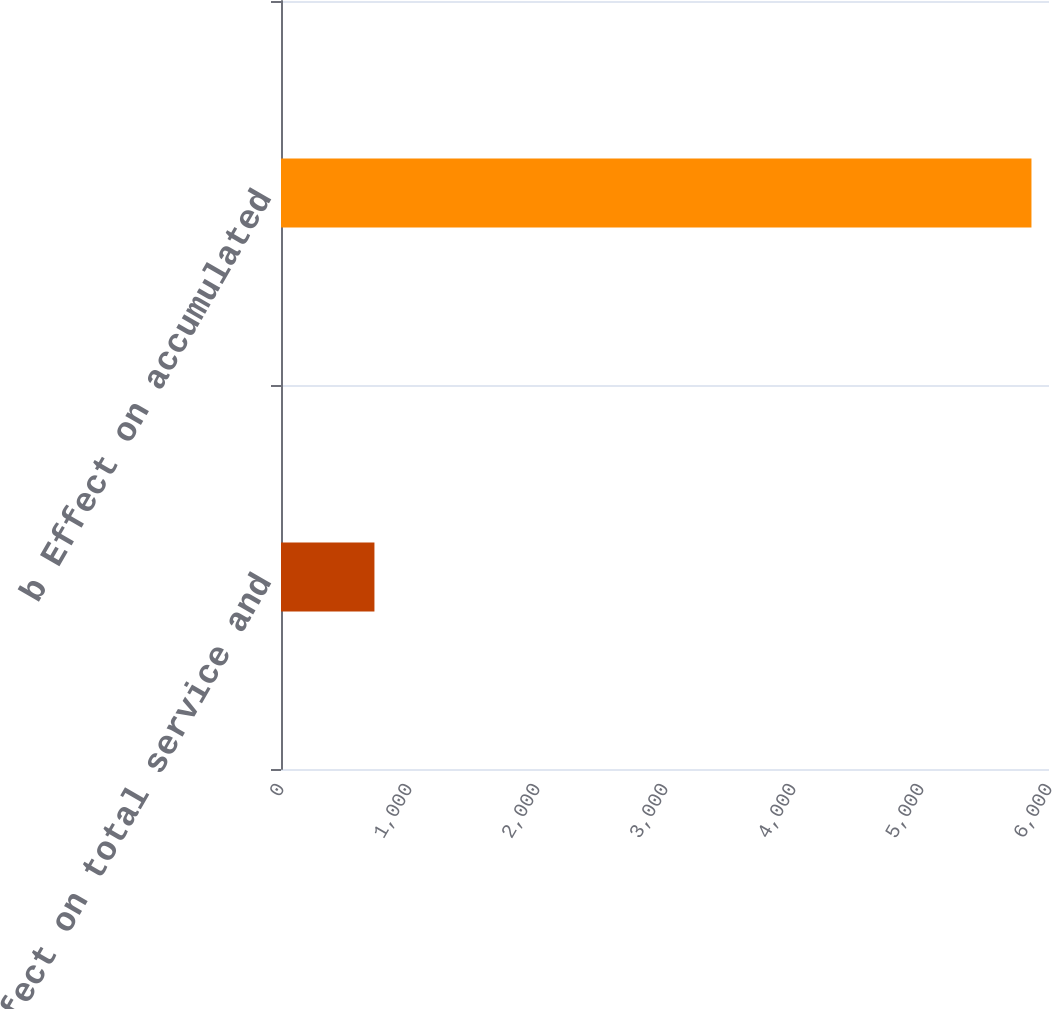<chart> <loc_0><loc_0><loc_500><loc_500><bar_chart><fcel>a Effect on total service and<fcel>b Effect on accumulated<nl><fcel>730<fcel>5863<nl></chart> 